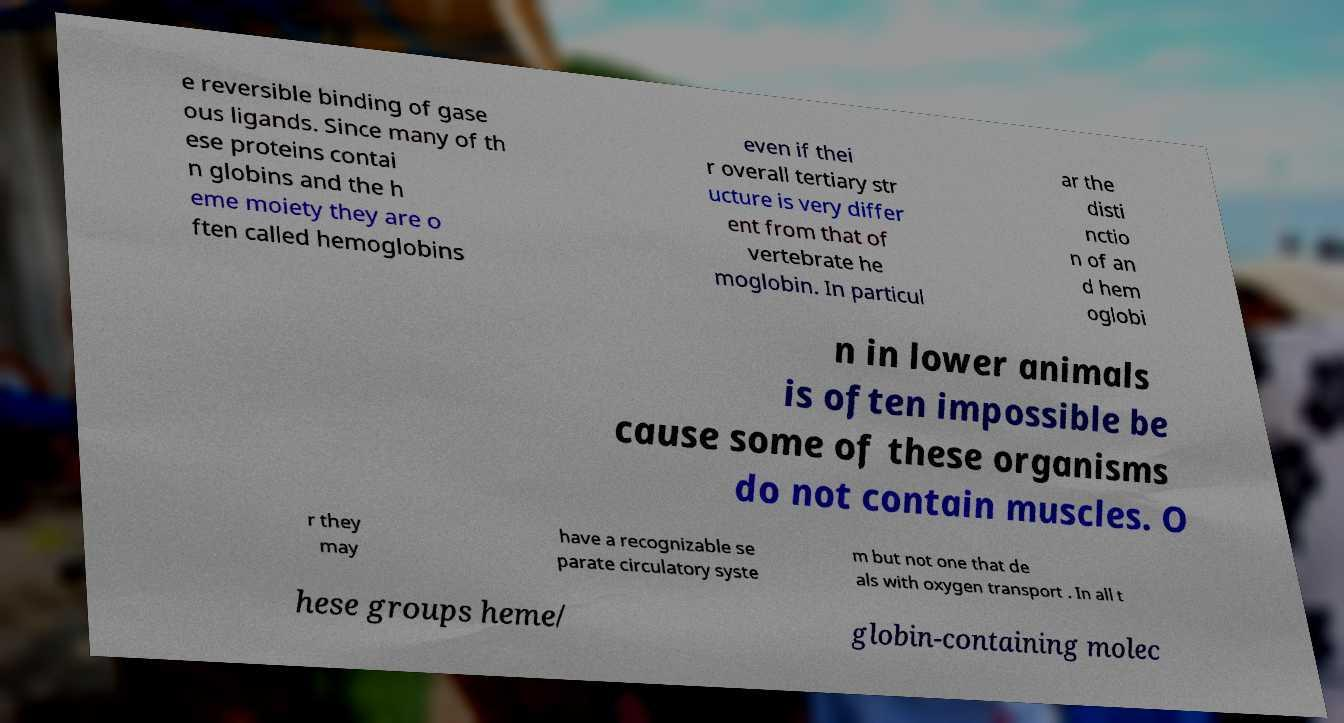Please identify and transcribe the text found in this image. e reversible binding of gase ous ligands. Since many of th ese proteins contai n globins and the h eme moiety they are o ften called hemoglobins even if thei r overall tertiary str ucture is very differ ent from that of vertebrate he moglobin. In particul ar the disti nctio n of an d hem oglobi n in lower animals is often impossible be cause some of these organisms do not contain muscles. O r they may have a recognizable se parate circulatory syste m but not one that de als with oxygen transport . In all t hese groups heme/ globin-containing molec 